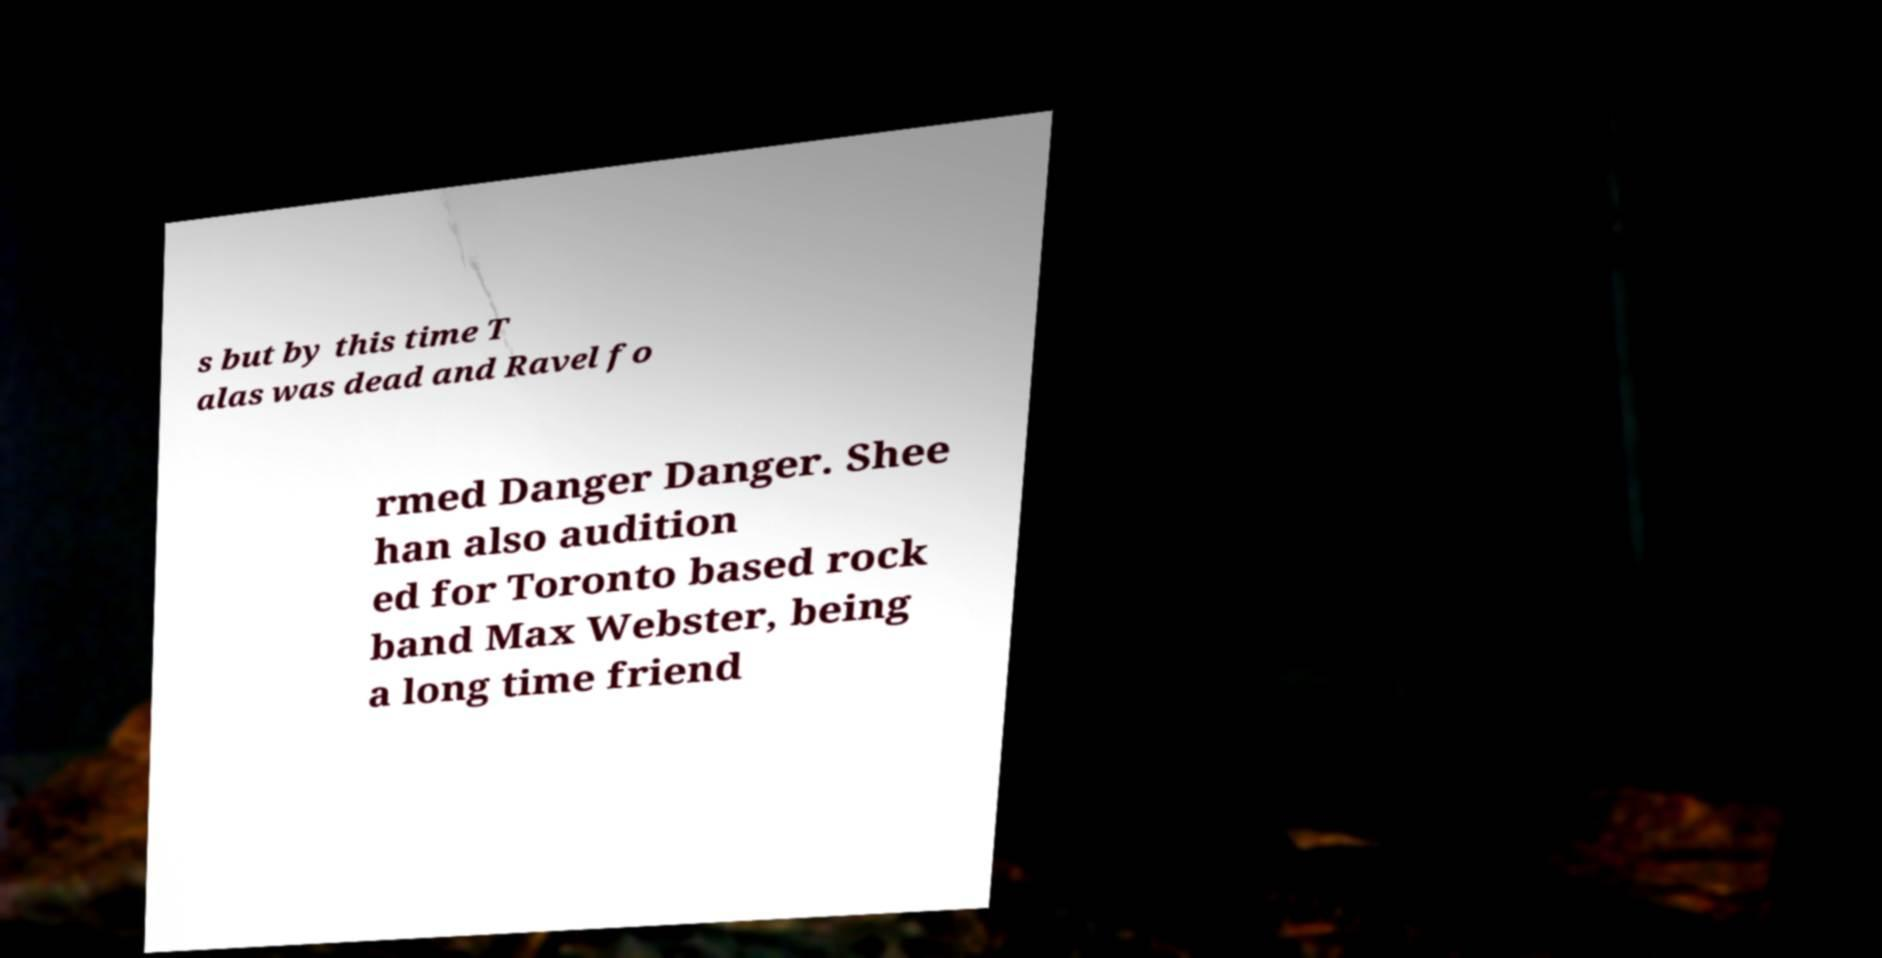Could you assist in decoding the text presented in this image and type it out clearly? s but by this time T alas was dead and Ravel fo rmed Danger Danger. Shee han also audition ed for Toronto based rock band Max Webster, being a long time friend 